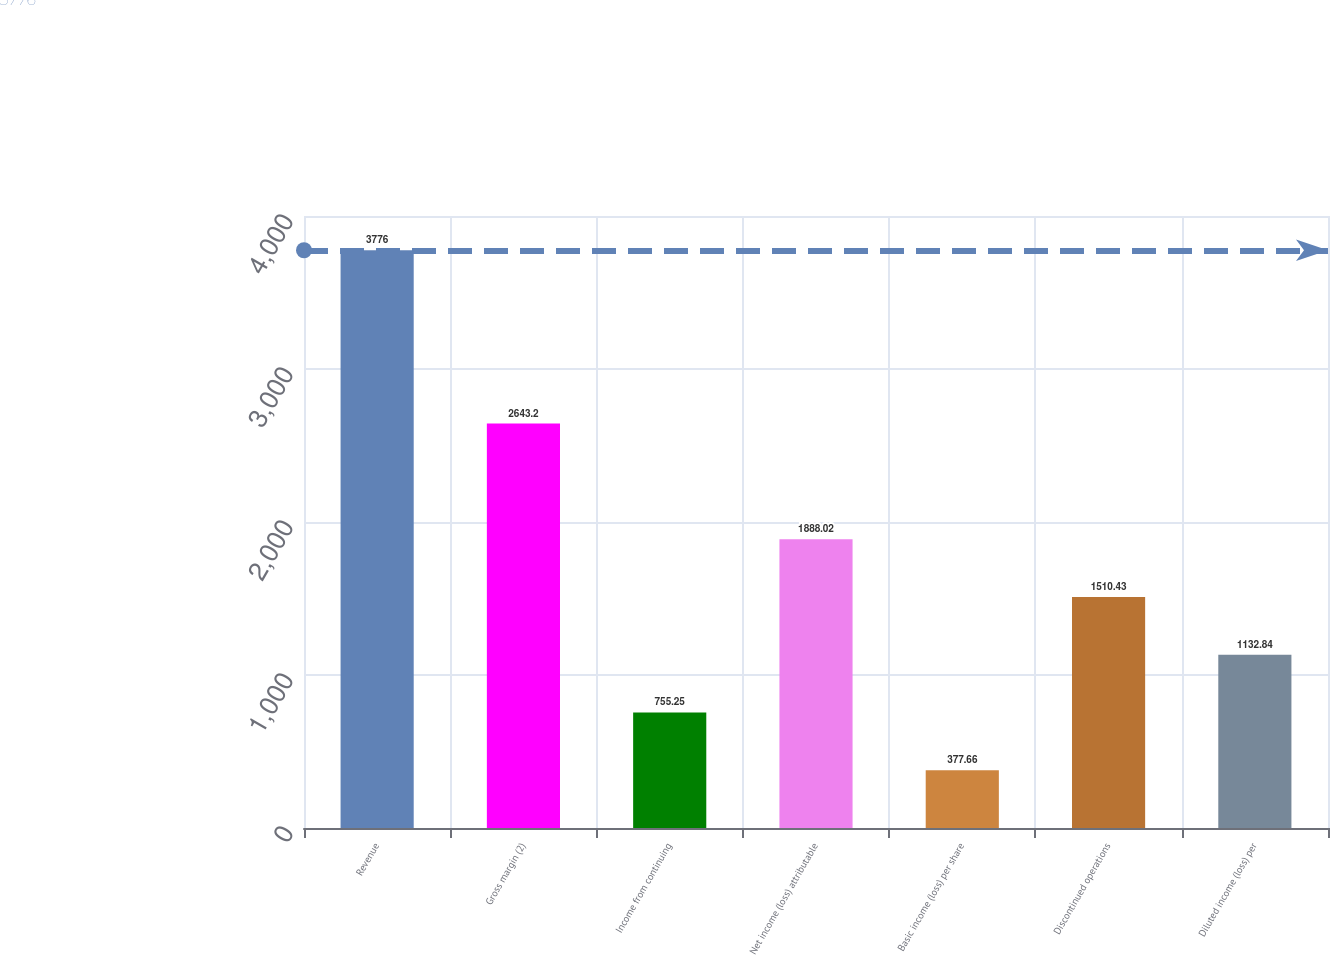Convert chart to OTSL. <chart><loc_0><loc_0><loc_500><loc_500><bar_chart><fcel>Revenue<fcel>Gross margin (2)<fcel>Income from continuing<fcel>Net income (loss) attributable<fcel>Basic income (loss) per share<fcel>Discontinued operations<fcel>Diluted income (loss) per<nl><fcel>3776<fcel>2643.2<fcel>755.25<fcel>1888.02<fcel>377.66<fcel>1510.43<fcel>1132.84<nl></chart> 